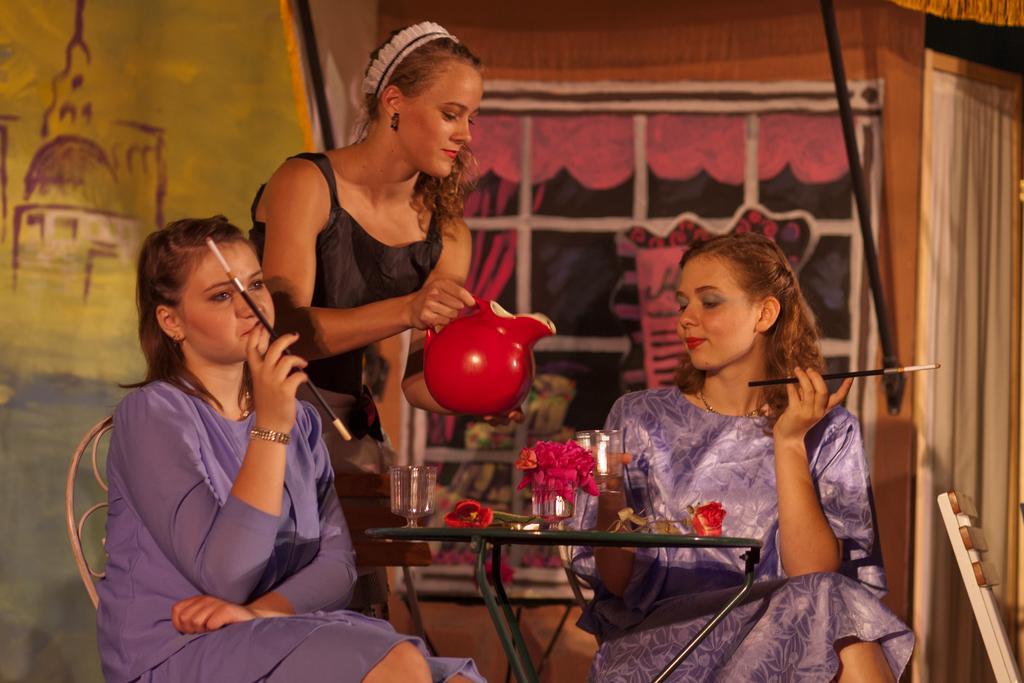Can you describe this image briefly? In this picture, we see two women are sitting on the chairs. They are holding the painting brushes in their hands. In front of them, we see a table on which the glasses, flower vase, flowers and an object are placed. Beside them, we see a woman is standing and she is holding a red color pot in her hands and she is smiling. In the background, we see the walls which are painted in yellow, pink and blue. On the right side, we see a chair and the curtains in white color. 